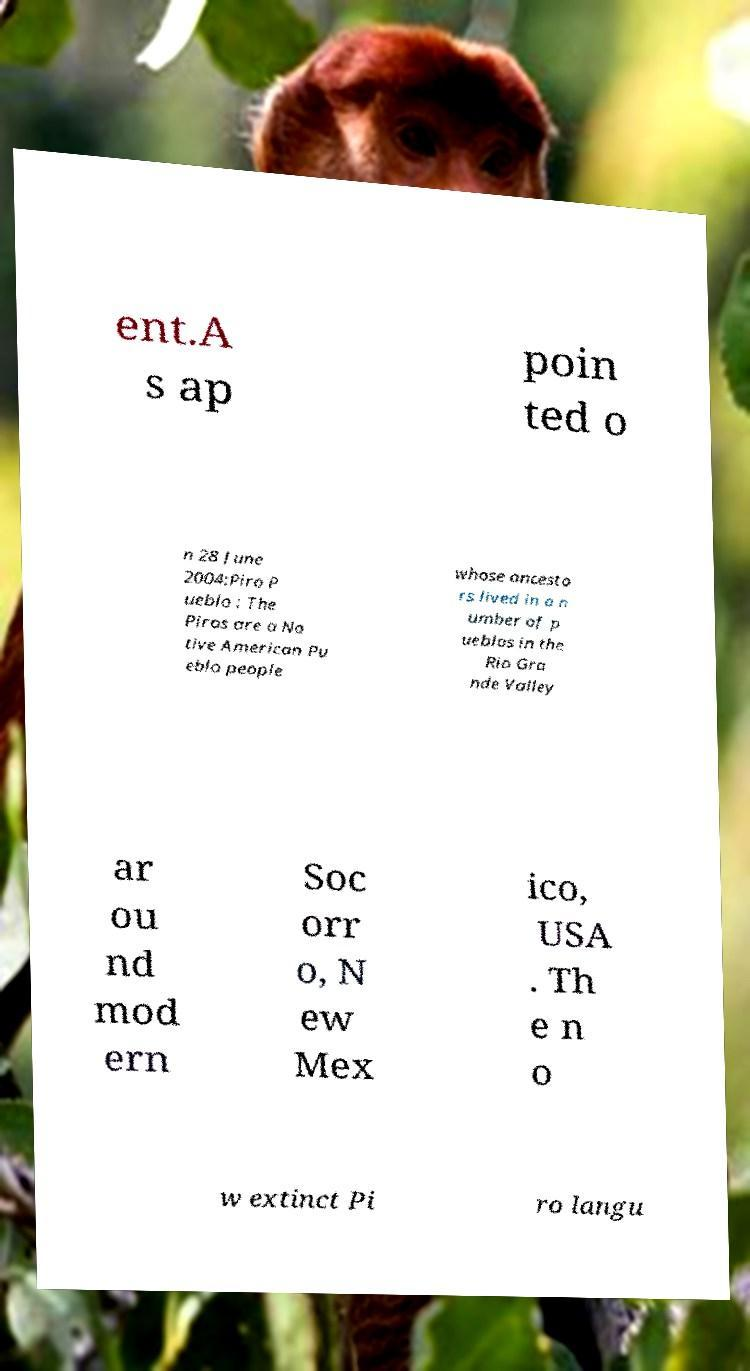Could you assist in decoding the text presented in this image and type it out clearly? ent.A s ap poin ted o n 28 June 2004:Piro P ueblo : The Piros are a Na tive American Pu eblo people whose ancesto rs lived in a n umber of p ueblos in the Rio Gra nde Valley ar ou nd mod ern Soc orr o, N ew Mex ico, USA . Th e n o w extinct Pi ro langu 